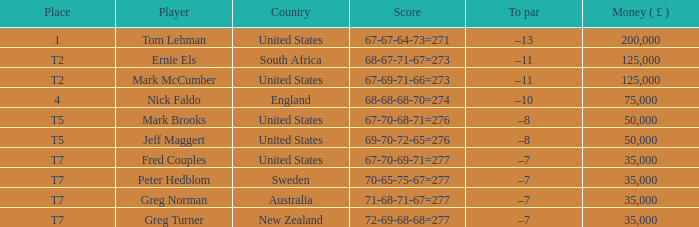What is To par, when Country is "United States", when Money ( £ ) is greater than 125,000, and when Score is "67-70-68-71=276"? None. 